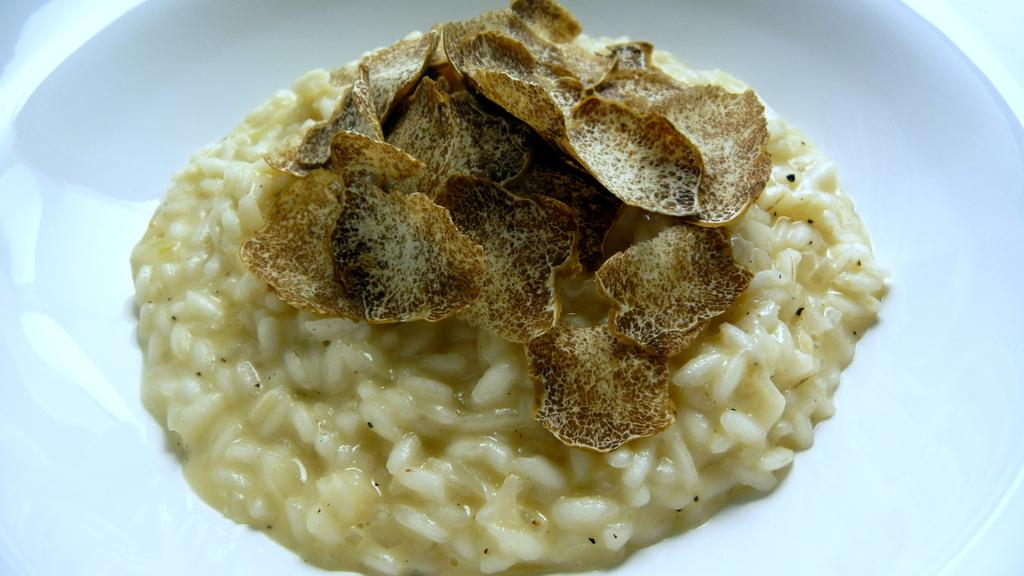What is on the plate that is visible in the image? There is food on a plate in the image. Where is the plate located in the image? The plate is in the center of the image. What type of comfort can be seen in the image? There is no reference to comfort in the image; it features a plate of food in the center. Is there a judge present in the image? There is no judge present in the image. 